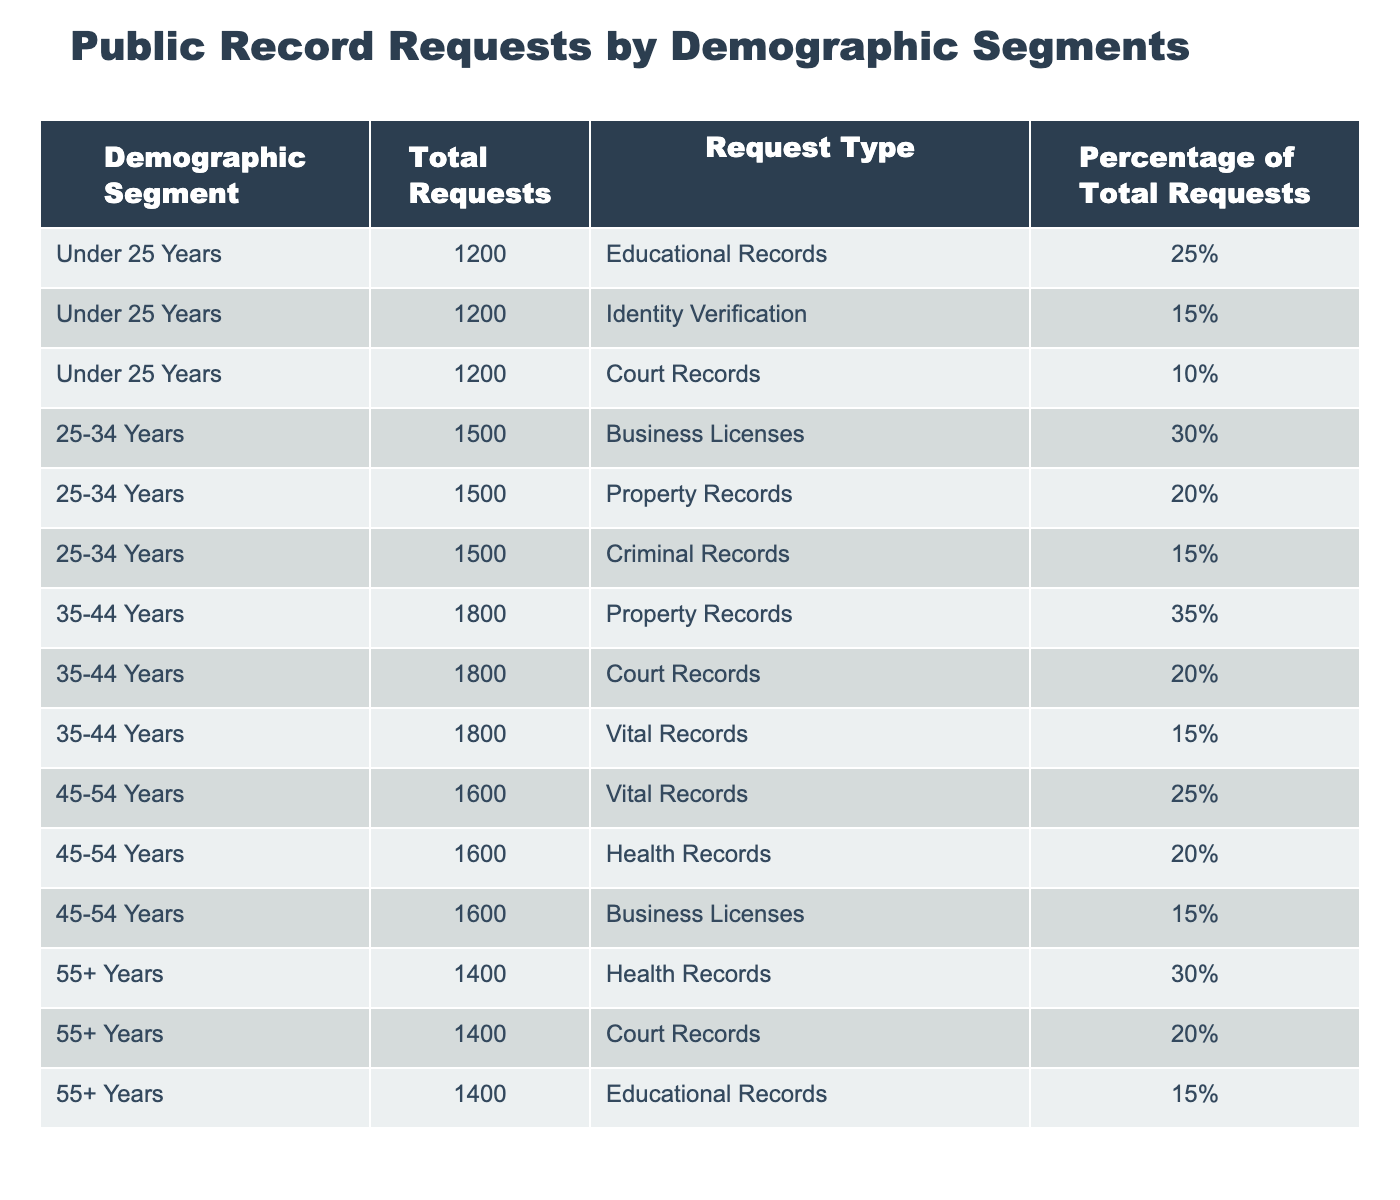What is the total number of public record requests made by individuals aged 25-34 years? The table indicates that the total requests for the demographic segment "25-34 Years" is listed as 1500.
Answer: 1500 Which type of record was the most requested by individuals aged 35-44 years? In the demographic segment "35-44 Years," the type of record with the highest number of requests is "Property Records," which has 35% of total requests.
Answer: Property Records Is it true that individuals aged 55 years and older made more requests for Health Records than any other group? By comparing the total Health Records requests made by each group, "55+ Years" has 30% of its total requests (1400), whereas other age segments have lower percentages for Health Records, confirming this statement is true.
Answer: Yes What percentage of total requests were made for Educational Records by the Under 25 Years demographic? For the "Under 25 Years" segment, Educational Records represented 25% of their total requests (1200). This percentage can be directly referenced from the table without any calculations needed.
Answer: 25% If we sum the percentage of requests for Court Records from all demographics, what do we get? From the table: Court Records for Under 25 Years is 10%, for 25-34 Years is 0% (not listed), for 35-44 Years is 20%, for 45-54 Years is 0% (not listed), and for 55+ Years is 20%. Adding these: 10 + 0 + 20 + 0 + 20 = 60%.
Answer: 60% 